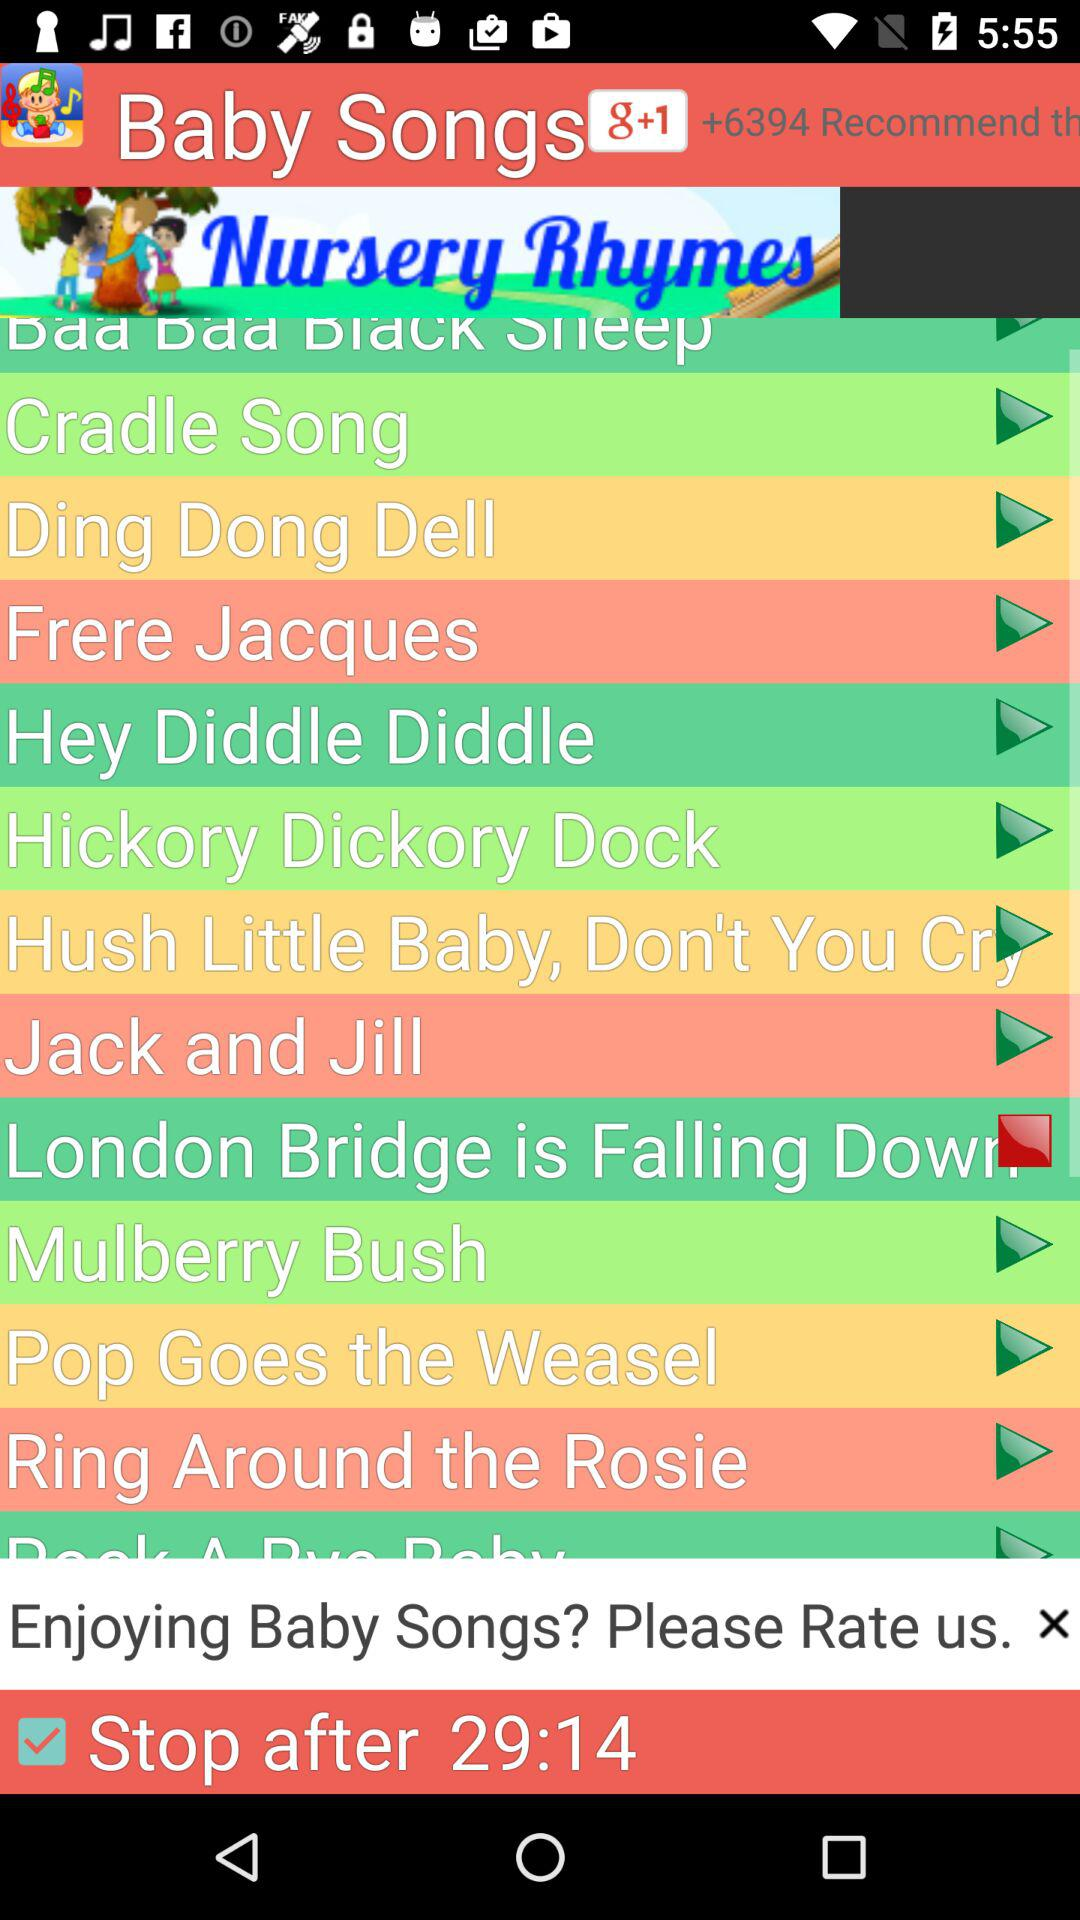What is the stop time for the song? The stop time for the song is 29:14. 